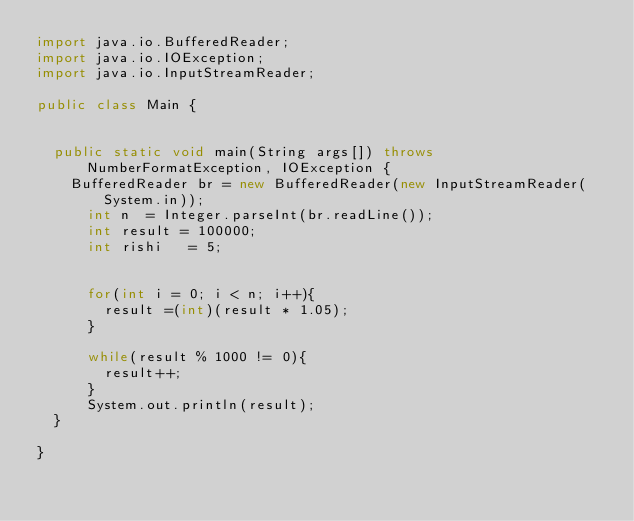<code> <loc_0><loc_0><loc_500><loc_500><_Java_>import java.io.BufferedReader;
import java.io.IOException;
import java.io.InputStreamReader;

public class Main {
	

	public static void main(String args[]) throws NumberFormatException, IOException {
		BufferedReader br = new BufferedReader(new InputStreamReader(System.in));
			int n  = Integer.parseInt(br.readLine());	
			int result = 100000;
			int rishi   = 5;

			
			for(int i = 0; i < n; i++){
				result =(int)(result * 1.05);
			}
		
			while(result % 1000 != 0){
				result++;
			}
			System.out.println(result);
	}
	
}</code> 